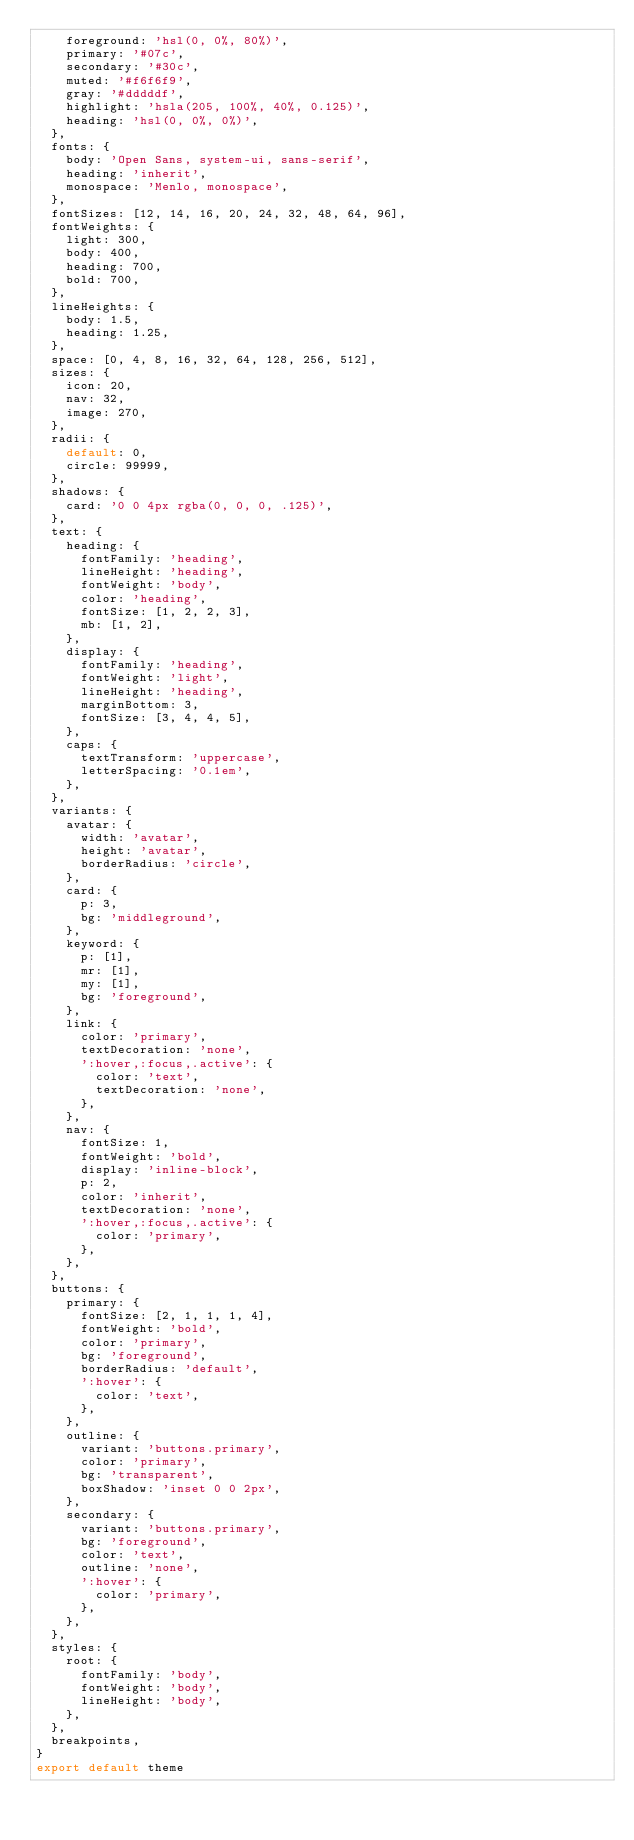<code> <loc_0><loc_0><loc_500><loc_500><_JavaScript_>    foreground: 'hsl(0, 0%, 80%)',
    primary: '#07c',
    secondary: '#30c',
    muted: '#f6f6f9',
    gray: '#dddddf',
    highlight: 'hsla(205, 100%, 40%, 0.125)',
    heading: 'hsl(0, 0%, 0%)',
  },
  fonts: {
    body: 'Open Sans, system-ui, sans-serif',
    heading: 'inherit',
    monospace: 'Menlo, monospace',
  },
  fontSizes: [12, 14, 16, 20, 24, 32, 48, 64, 96],
  fontWeights: {
    light: 300,
    body: 400,
    heading: 700,
    bold: 700,
  },
  lineHeights: {
    body: 1.5,
    heading: 1.25,
  },
  space: [0, 4, 8, 16, 32, 64, 128, 256, 512],
  sizes: {
    icon: 20,
    nav: 32,
    image: 270,
  },
  radii: {
    default: 0,
    circle: 99999,
  },
  shadows: {
    card: '0 0 4px rgba(0, 0, 0, .125)',
  },
  text: {
    heading: {
      fontFamily: 'heading',
      lineHeight: 'heading',
      fontWeight: 'body',
      color: 'heading',
      fontSize: [1, 2, 2, 3],
      mb: [1, 2],
    },
    display: {
      fontFamily: 'heading',
      fontWeight: 'light',
      lineHeight: 'heading',
      marginBottom: 3,
      fontSize: [3, 4, 4, 5],
    },
    caps: {
      textTransform: 'uppercase',
      letterSpacing: '0.1em',
    },
  },
  variants: {
    avatar: {
      width: 'avatar',
      height: 'avatar',
      borderRadius: 'circle',
    },
    card: {
      p: 3,
      bg: 'middleground',
    },
    keyword: {
      p: [1],
      mr: [1],
      my: [1],
      bg: 'foreground',
    },
    link: {
      color: 'primary',
      textDecoration: 'none',
      ':hover,:focus,.active': {
        color: 'text',
        textDecoration: 'none',
      },
    },
    nav: {
      fontSize: 1,
      fontWeight: 'bold',
      display: 'inline-block',
      p: 2,
      color: 'inherit',
      textDecoration: 'none',
      ':hover,:focus,.active': {
        color: 'primary',
      },
    },
  },
  buttons: {
    primary: {
      fontSize: [2, 1, 1, 1, 4],
      fontWeight: 'bold',
      color: 'primary',
      bg: 'foreground',
      borderRadius: 'default',
      ':hover': {
        color: 'text',
      },
    },
    outline: {
      variant: 'buttons.primary',
      color: 'primary',
      bg: 'transparent',
      boxShadow: 'inset 0 0 2px',
    },
    secondary: {
      variant: 'buttons.primary',
      bg: 'foreground',
      color: 'text',
      outline: 'none',
      ':hover': {
        color: 'primary',
      },
    },
  },
  styles: {
    root: {
      fontFamily: 'body',
      fontWeight: 'body',
      lineHeight: 'body',
    },
  },
  breakpoints,
}
export default theme
</code> 